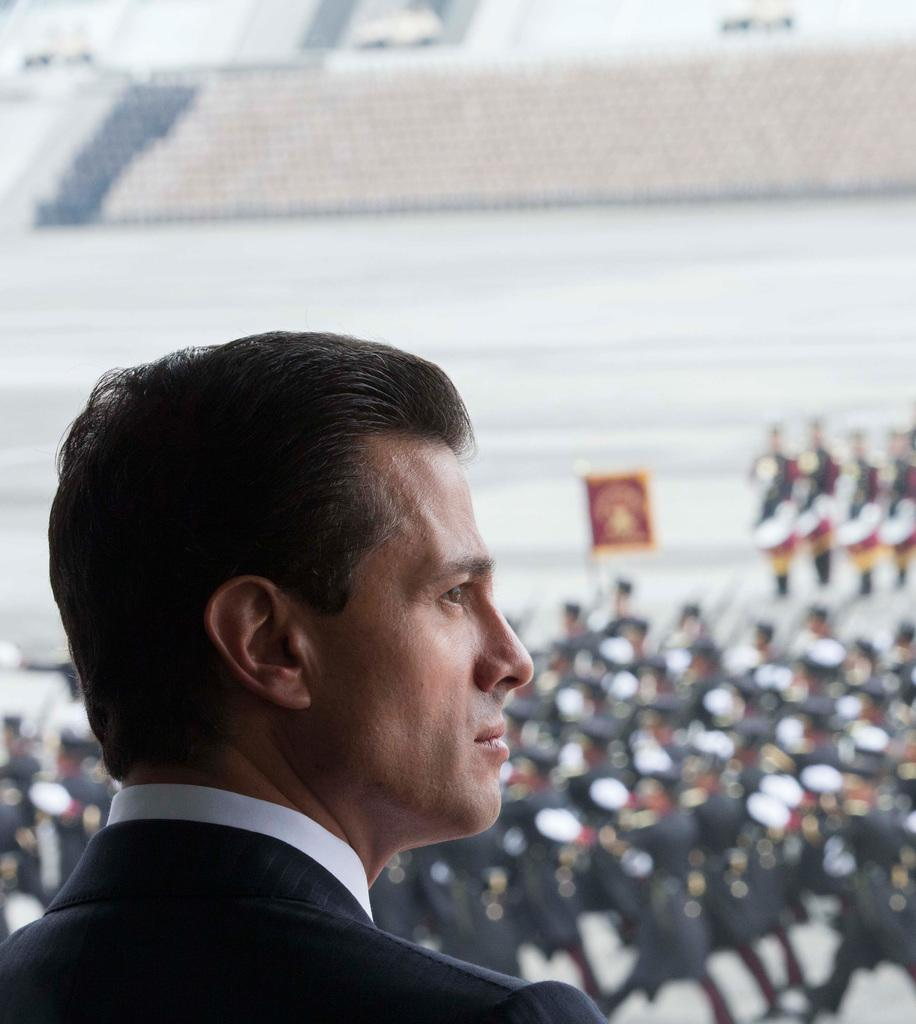Who is the main subject in the image? There is a man in the image. What can be seen in the background of the image? There are people wearing uniforms and bleachers in the background of the image. What type of crow is sitting on the man's shoulder in the image? There is no crow present in the image. What is the man's income based on the image? The image does not provide any information about the man's income. 